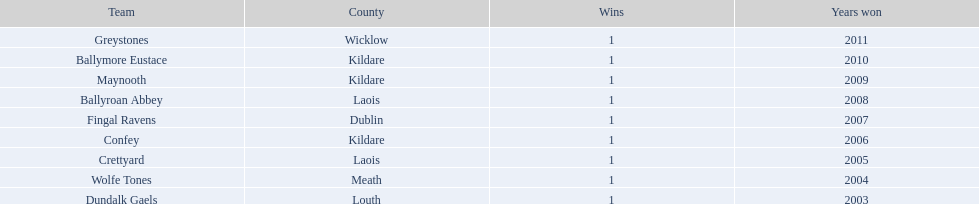Ballymore eustace is from the same county as what team that won in 2009? Maynooth. 